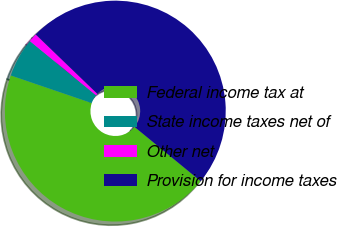<chart> <loc_0><loc_0><loc_500><loc_500><pie_chart><fcel>Federal income tax at<fcel>State income taxes net of<fcel>Other net<fcel>Provision for income taxes<nl><fcel>44.3%<fcel>5.7%<fcel>1.27%<fcel>48.73%<nl></chart> 